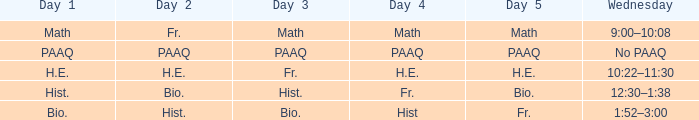What is the day 3 when day 4 is fr.? Hist. 